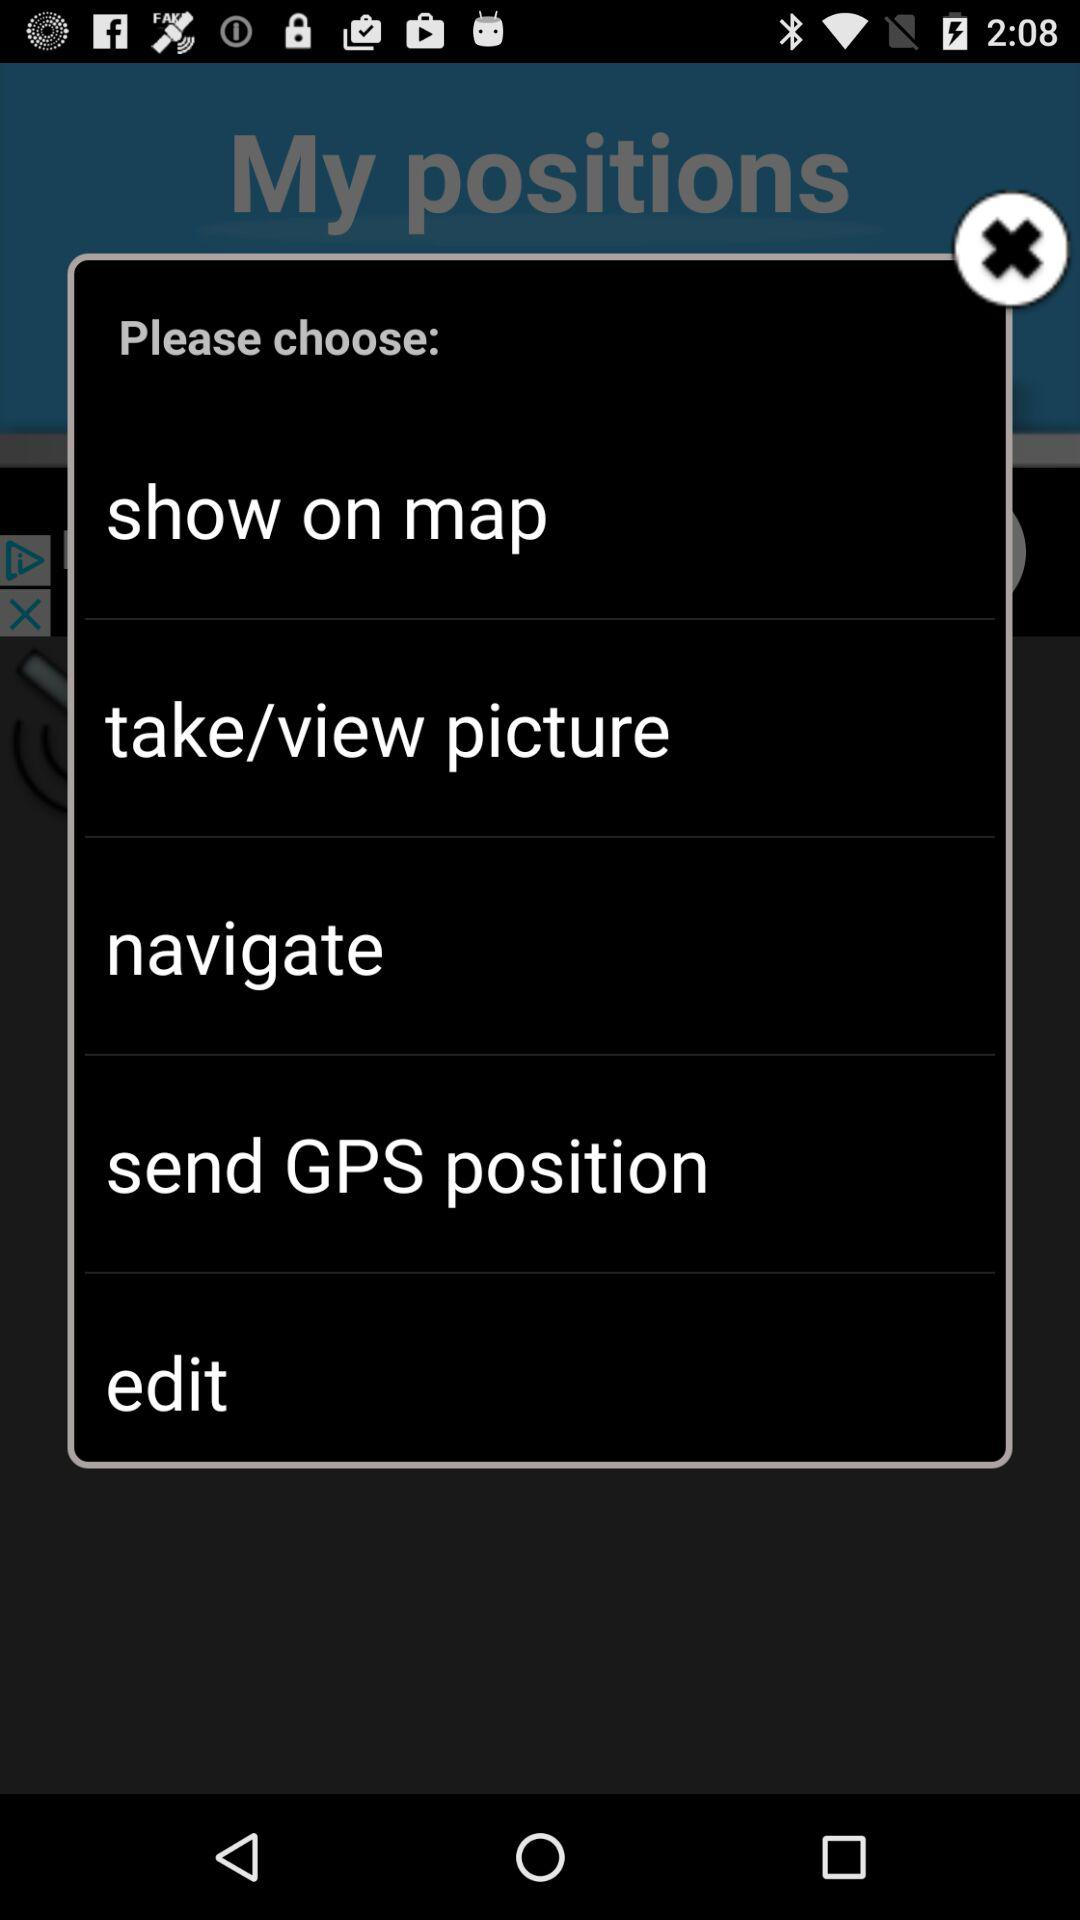How many options are there to share a location?
Answer the question using a single word or phrase. 5 